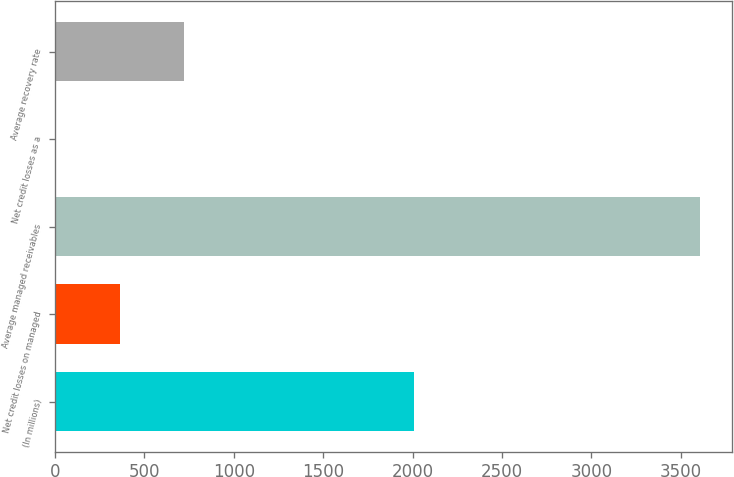<chart> <loc_0><loc_0><loc_500><loc_500><bar_chart><fcel>(In millions)<fcel>Net credit losses on managed<fcel>Average managed receivables<fcel>Net credit losses as a<fcel>Average recovery rate<nl><fcel>2008<fcel>361.79<fcel>3608.4<fcel>1.06<fcel>722.52<nl></chart> 